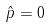Convert formula to latex. <formula><loc_0><loc_0><loc_500><loc_500>\hat { p } = 0</formula> 